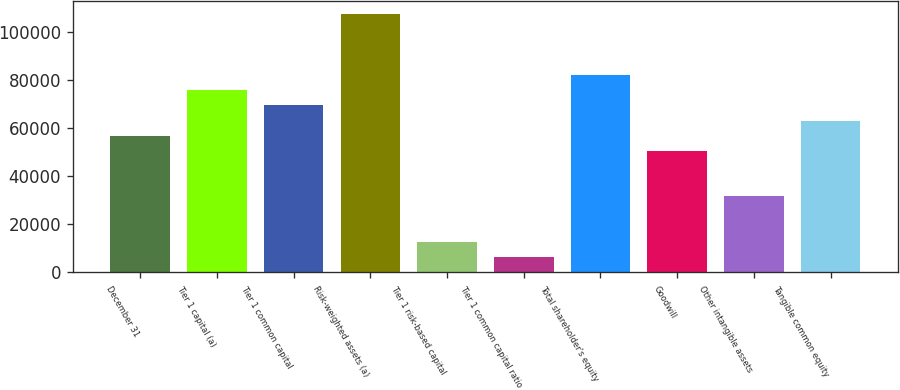Convert chart. <chart><loc_0><loc_0><loc_500><loc_500><bar_chart><fcel>December 31<fcel>Tier 1 capital (a)<fcel>Tier 1 common capital<fcel>Risk-weighted assets (a)<fcel>Tier 1 risk-based capital<fcel>Tier 1 common capital ratio<fcel>Total shareholder's equity<fcel>Goodwill<fcel>Other intangible assets<fcel>Tangible common equity<nl><fcel>56920.6<fcel>75890.7<fcel>69567.3<fcel>107508<fcel>12657<fcel>6333.64<fcel>82214.1<fcel>50597.2<fcel>31627.1<fcel>63244<nl></chart> 